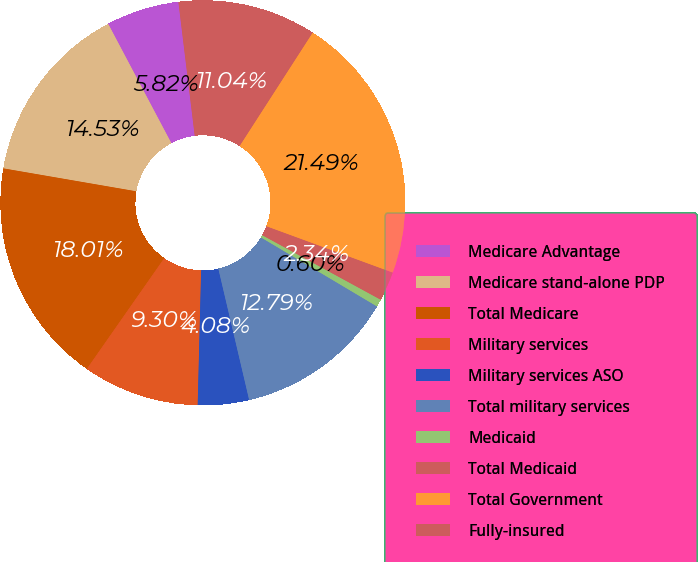Convert chart to OTSL. <chart><loc_0><loc_0><loc_500><loc_500><pie_chart><fcel>Medicare Advantage<fcel>Medicare stand-alone PDP<fcel>Total Medicare<fcel>Military services<fcel>Military services ASO<fcel>Total military services<fcel>Medicaid<fcel>Total Medicaid<fcel>Total Government<fcel>Fully-insured<nl><fcel>5.82%<fcel>14.53%<fcel>18.01%<fcel>9.3%<fcel>4.08%<fcel>12.79%<fcel>0.6%<fcel>2.34%<fcel>21.49%<fcel>11.04%<nl></chart> 